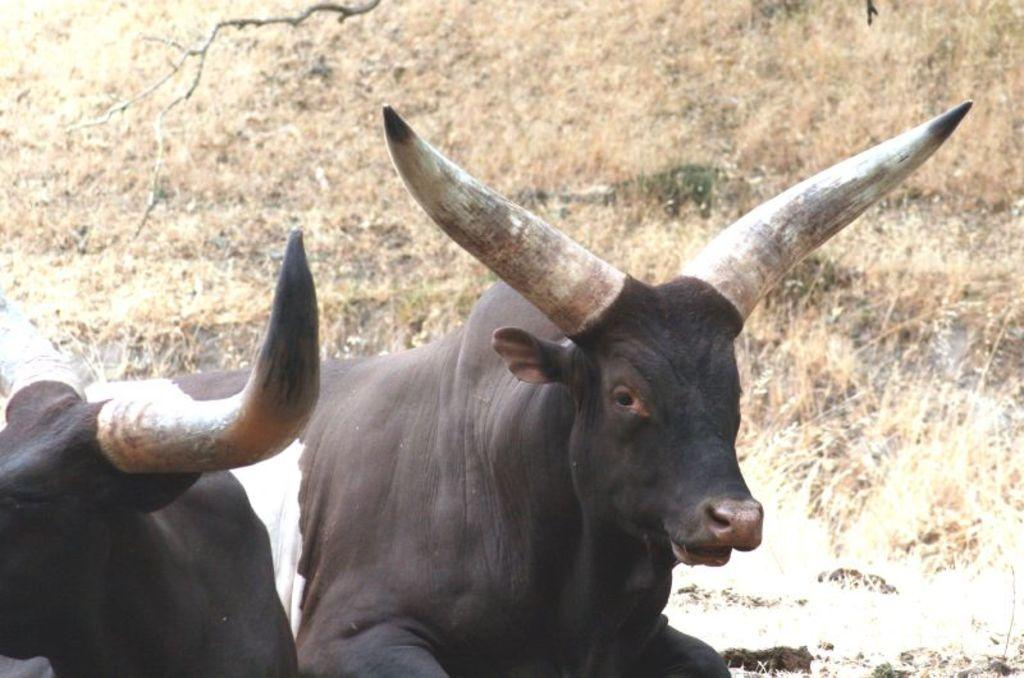What animals are in the center of the image? There are two cows in the center of the image. What color are the cows? The cows are in black and white color. What type of vegetation is visible in the background of the image? There is grass in the background of the image. What else can be seen in the background of the image? There are branches in the background of the image. What type of bird is perched on the key in the image? There is no bird or key present in the image; it features two black and white cows with grass and branches in the background. 